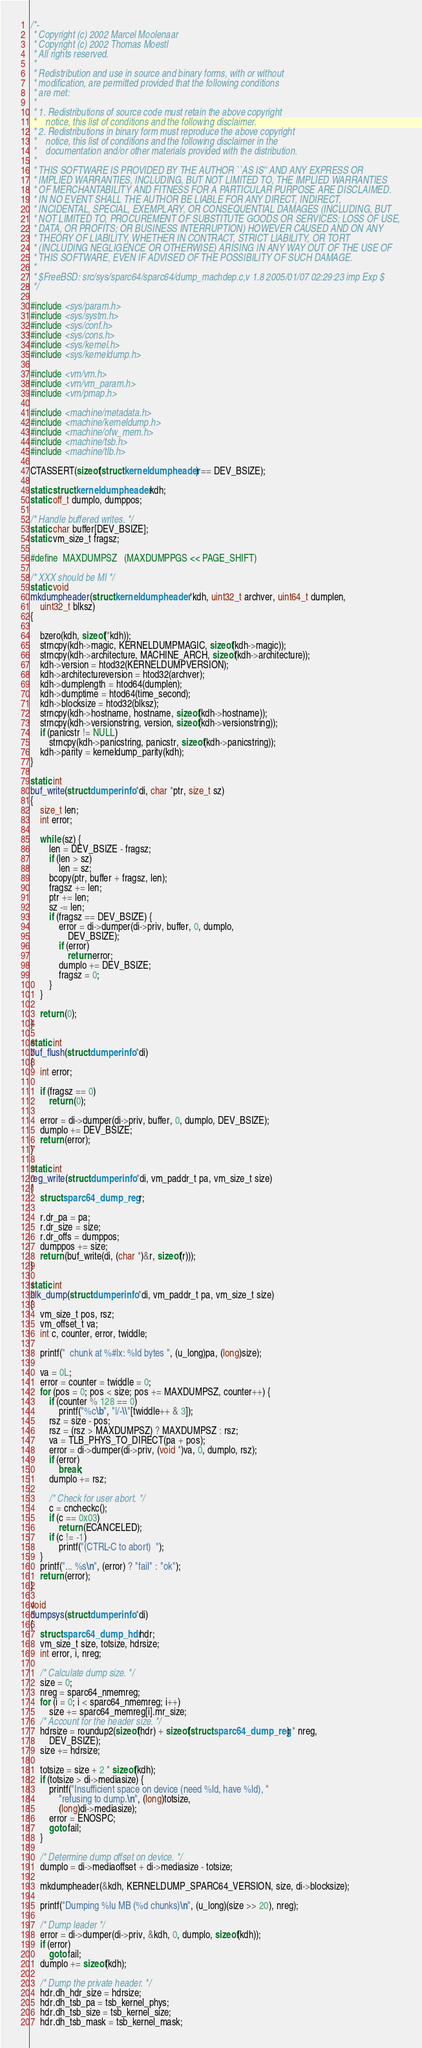Convert code to text. <code><loc_0><loc_0><loc_500><loc_500><_C_>/*-
 * Copyright (c) 2002 Marcel Moolenaar
 * Copyright (c) 2002 Thomas Moestl
 * All rights reserved.
 *
 * Redistribution and use in source and binary forms, with or without
 * modification, are permitted provided that the following conditions
 * are met:
 *
 * 1. Redistributions of source code must retain the above copyright
 *    notice, this list of conditions and the following disclaimer.
 * 2. Redistributions in binary form must reproduce the above copyright
 *    notice, this list of conditions and the following disclaimer in the
 *    documentation and/or other materials provided with the distribution.
 *
 * THIS SOFTWARE IS PROVIDED BY THE AUTHOR ``AS IS'' AND ANY EXPRESS OR
 * IMPLIED WARRANTIES, INCLUDING, BUT NOT LIMITED TO, THE IMPLIED WARRANTIES
 * OF MERCHANTABILITY AND FITNESS FOR A PARTICULAR PURPOSE ARE DISCLAIMED.
 * IN NO EVENT SHALL THE AUTHOR BE LIABLE FOR ANY DIRECT, INDIRECT,
 * INCIDENTAL, SPECIAL, EXEMPLARY, OR CONSEQUENTIAL DAMAGES (INCLUDING, BUT
 * NOT LIMITED TO, PROCUREMENT OF SUBSTITUTE GOODS OR SERVICES; LOSS OF USE,
 * DATA, OR PROFITS; OR BUSINESS INTERRUPTION) HOWEVER CAUSED AND ON ANY
 * THEORY OF LIABILITY, WHETHER IN CONTRACT, STRICT LIABILITY, OR TORT
 * (INCLUDING NEGLIGENCE OR OTHERWISE) ARISING IN ANY WAY OUT OF THE USE OF
 * THIS SOFTWARE, EVEN IF ADVISED OF THE POSSIBILITY OF SUCH DAMAGE.
 *
 * $FreeBSD: src/sys/sparc64/sparc64/dump_machdep.c,v 1.8 2005/01/07 02:29:23 imp Exp $
 */

#include <sys/param.h>
#include <sys/systm.h>
#include <sys/conf.h>
#include <sys/cons.h>
#include <sys/kernel.h>
#include <sys/kerneldump.h>

#include <vm/vm.h>
#include <vm/vm_param.h>
#include <vm/pmap.h>

#include <machine/metadata.h>
#include <machine/kerneldump.h>
#include <machine/ofw_mem.h>
#include <machine/tsb.h>
#include <machine/tlb.h>

CTASSERT(sizeof(struct kerneldumpheader) == DEV_BSIZE);

static struct kerneldumpheader kdh;
static off_t dumplo, dumppos;

/* Handle buffered writes. */
static char buffer[DEV_BSIZE];
static vm_size_t fragsz;

#define	MAXDUMPSZ	(MAXDUMPPGS << PAGE_SHIFT)

/* XXX should be MI */
static void
mkdumpheader(struct kerneldumpheader *kdh, uint32_t archver, uint64_t dumplen,
    uint32_t blksz)
{

	bzero(kdh, sizeof(*kdh));
	strncpy(kdh->magic, KERNELDUMPMAGIC, sizeof(kdh->magic));
	strncpy(kdh->architecture, MACHINE_ARCH, sizeof(kdh->architecture));
	kdh->version = htod32(KERNELDUMPVERSION);
	kdh->architectureversion = htod32(archver);
	kdh->dumplength = htod64(dumplen);
	kdh->dumptime = htod64(time_second);
	kdh->blocksize = htod32(blksz);
	strncpy(kdh->hostname, hostname, sizeof(kdh->hostname));
	strncpy(kdh->versionstring, version, sizeof(kdh->versionstring));
	if (panicstr != NULL)
		strncpy(kdh->panicstring, panicstr, sizeof(kdh->panicstring));
	kdh->parity = kerneldump_parity(kdh);
}

static int
buf_write(struct dumperinfo *di, char *ptr, size_t sz)
{
	size_t len;
	int error;

	while (sz) {
		len = DEV_BSIZE - fragsz;
		if (len > sz)
			len = sz;
		bcopy(ptr, buffer + fragsz, len);
		fragsz += len;
		ptr += len;
		sz -= len;
		if (fragsz == DEV_BSIZE) {
			error = di->dumper(di->priv, buffer, 0, dumplo,
			    DEV_BSIZE);
			if (error)
				return error;
			dumplo += DEV_BSIZE;
			fragsz = 0;
		}
	}

	return (0);
}

static int
buf_flush(struct dumperinfo *di)
{
	int error;

	if (fragsz == 0)
		return (0);

	error = di->dumper(di->priv, buffer, 0, dumplo, DEV_BSIZE);
	dumplo += DEV_BSIZE;
	return (error);
}

static int
reg_write(struct dumperinfo *di, vm_paddr_t pa, vm_size_t size)
{
	struct sparc64_dump_reg r;

	r.dr_pa = pa;
	r.dr_size = size;
	r.dr_offs = dumppos;
	dumppos += size;
	return (buf_write(di, (char *)&r, sizeof(r)));
}

static int
blk_dump(struct dumperinfo *di, vm_paddr_t pa, vm_size_t size)
{
	vm_size_t pos, rsz;
	vm_offset_t va;
	int c, counter, error, twiddle;

	printf("  chunk at %#lx: %ld bytes ", (u_long)pa, (long)size);

	va = 0L;
	error = counter = twiddle = 0;
	for (pos = 0; pos < size; pos += MAXDUMPSZ, counter++) {
		if (counter % 128 == 0)
			printf("%c\b", "|/-\\"[twiddle++ & 3]);
		rsz = size - pos;
		rsz = (rsz > MAXDUMPSZ) ? MAXDUMPSZ : rsz;
		va = TLB_PHYS_TO_DIRECT(pa + pos);
		error = di->dumper(di->priv, (void *)va, 0, dumplo, rsz);
		if (error)
			break;
		dumplo += rsz;

		/* Check for user abort. */
		c = cncheckc();
		if (c == 0x03)
			return (ECANCELED);
		if (c != -1)
			printf("(CTRL-C to abort)  ");
	}
	printf("... %s\n", (error) ? "fail" : "ok");
	return (error);
}

void
dumpsys(struct dumperinfo *di)
{
	struct sparc64_dump_hdr hdr;
	vm_size_t size, totsize, hdrsize;
	int error, i, nreg;

	/* Calculate dump size. */
	size = 0;
	nreg = sparc64_nmemreg;
	for (i = 0; i < sparc64_nmemreg; i++)
		size += sparc64_memreg[i].mr_size;
	/* Account for the header size. */
	hdrsize = roundup2(sizeof(hdr) + sizeof(struct sparc64_dump_reg) * nreg,
	    DEV_BSIZE);
	size += hdrsize;

	totsize = size + 2 * sizeof(kdh);
	if (totsize > di->mediasize) {
		printf("Insufficient space on device (need %ld, have %ld), "
		    "refusing to dump.\n", (long)totsize,
		    (long)di->mediasize);
		error = ENOSPC;
		goto fail;
	}

	/* Determine dump offset on device. */
	dumplo = di->mediaoffset + di->mediasize - totsize;

	mkdumpheader(&kdh, KERNELDUMP_SPARC64_VERSION, size, di->blocksize);

	printf("Dumping %lu MB (%d chunks)\n", (u_long)(size >> 20), nreg);

	/* Dump leader */
	error = di->dumper(di->priv, &kdh, 0, dumplo, sizeof(kdh));
	if (error)
		goto fail;
	dumplo += sizeof(kdh);

	/* Dump the private header. */
	hdr.dh_hdr_size = hdrsize;
	hdr.dh_tsb_pa = tsb_kernel_phys;
	hdr.dh_tsb_size = tsb_kernel_size;
	hdr.dh_tsb_mask = tsb_kernel_mask;</code> 